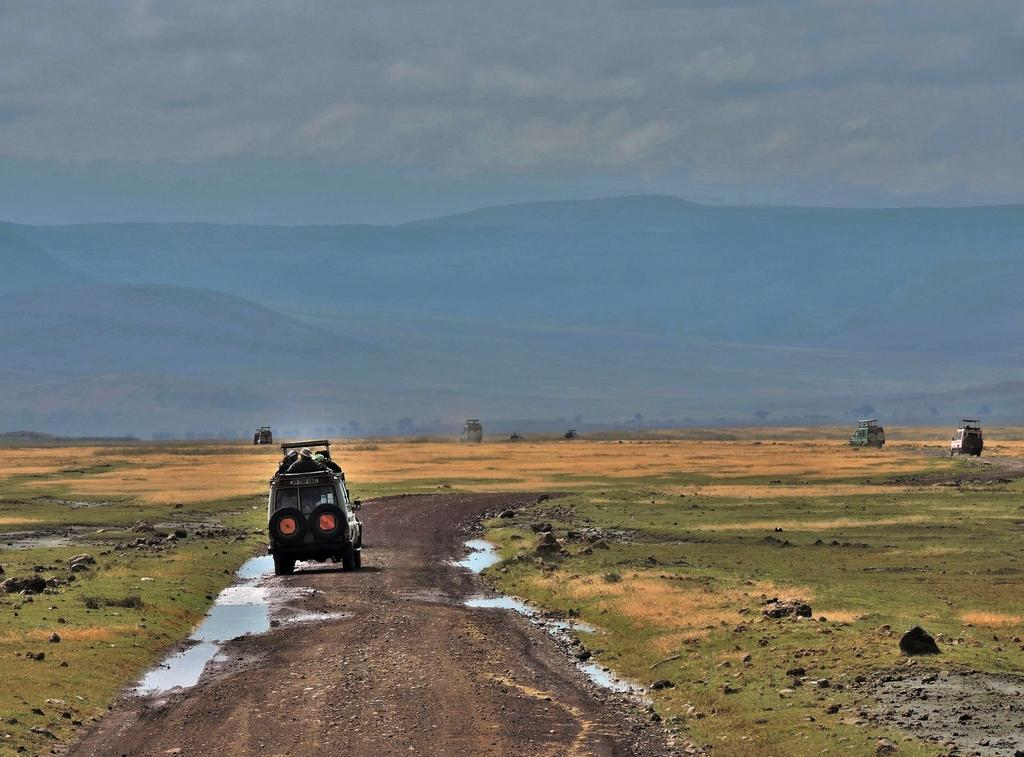What can be seen on the road in the image? There are vehicles on the road in the image. What is visible in the distance behind the vehicles? There are mountains and the sky visible in the background of the image. What type of terrain is present in the image? There is grass present in the image. What else can be seen in the image besides the vehicles and terrain? There is water visible in the image. What type of jeans is the coach wearing in the image? There is no coach or jeans present in the image; it features vehicles on a road with a mountainous background. What type of music can be heard playing in the image? There is no music present in the image; it is a still photograph of vehicles on a road. 